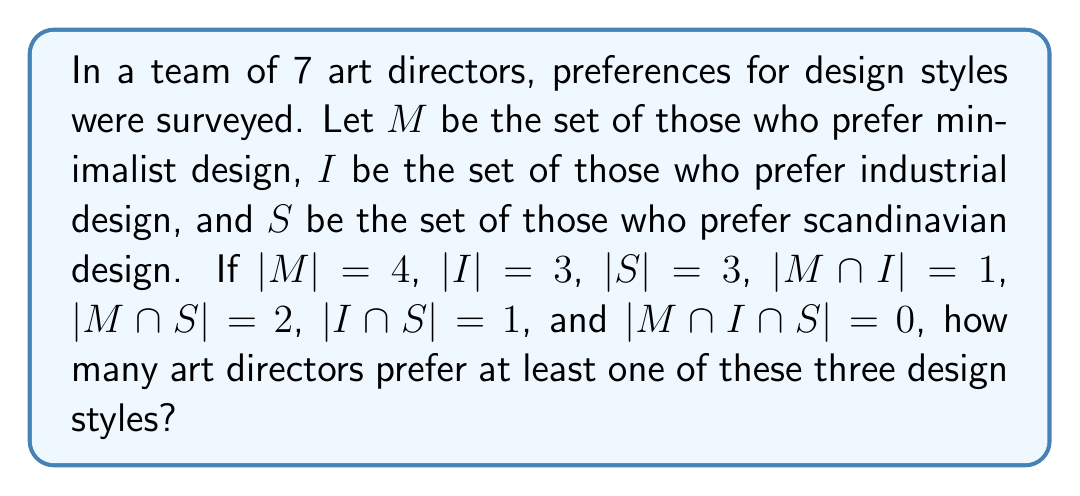Give your solution to this math problem. To solve this problem, we'll use the principle of inclusion-exclusion for three sets:

$$|M \cup I \cup S| = |M| + |I| + |S| - |M \cap I| - |M \cap S| - |I \cap S| + |M \cap I \cap S|$$

Let's substitute the given values:

$$|M \cup I \cup S| = 4 + 3 + 3 - 1 - 2 - 1 + 0$$

Now, let's calculate step by step:

1) First, add the individual set sizes:
   $4 + 3 + 3 = 10$

2) Subtract the pairwise intersections:
   $10 - 1 - 2 - 1 = 6$

3) Add back the triple intersection (which is 0 in this case):
   $6 + 0 = 6$

Therefore, the number of art directors who prefer at least one of these three design styles is 6.

This makes sense in the context of the problem, as it's less than the total team size of 7, indicating that one art director might prefer a different style not mentioned in the survey.
Answer: 6 art directors 